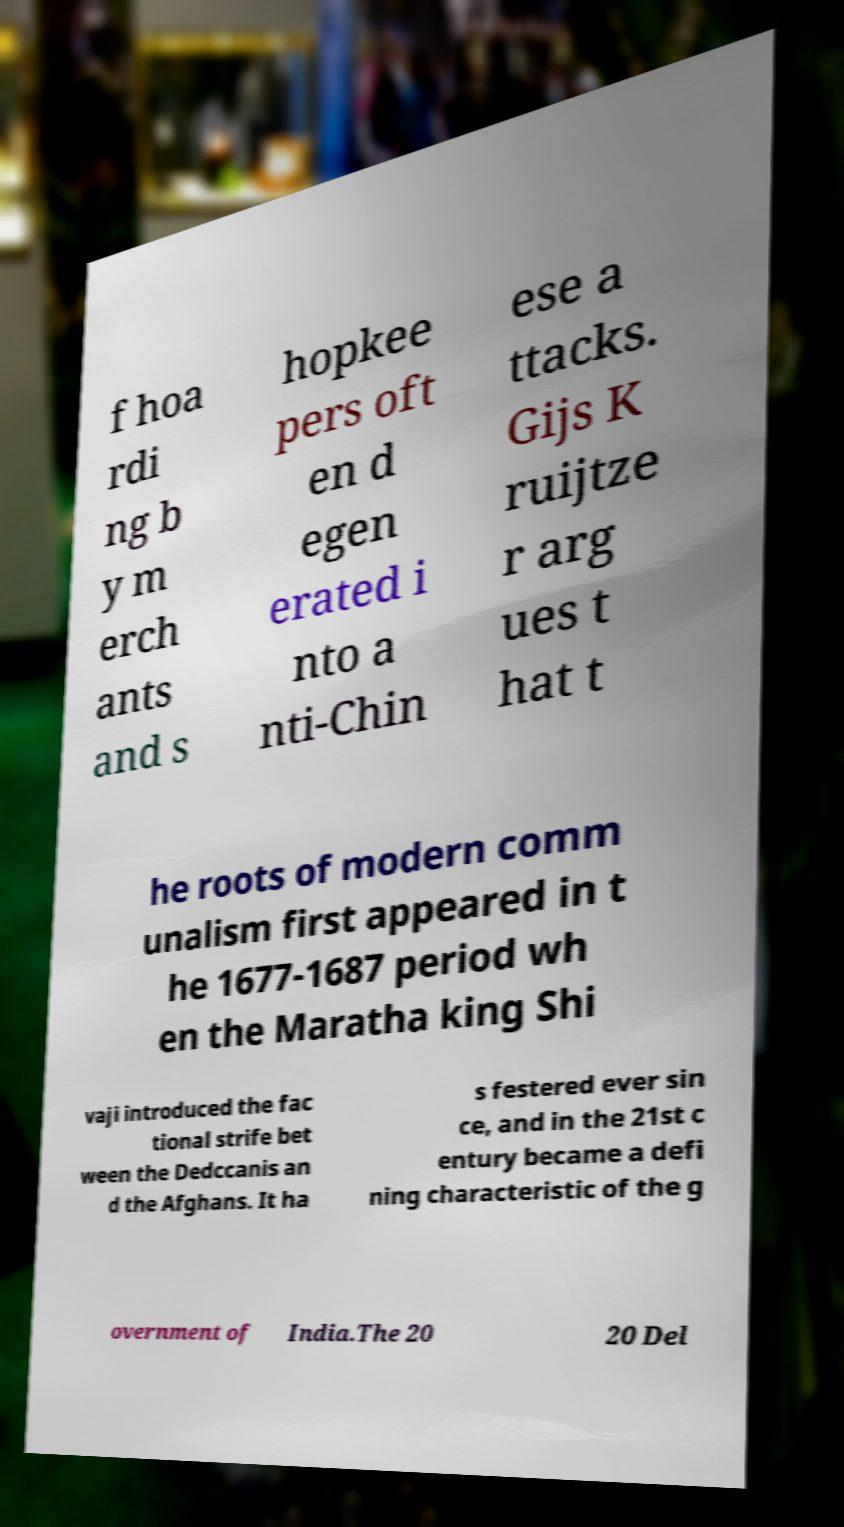For documentation purposes, I need the text within this image transcribed. Could you provide that? f hoa rdi ng b y m erch ants and s hopkee pers oft en d egen erated i nto a nti-Chin ese a ttacks. Gijs K ruijtze r arg ues t hat t he roots of modern comm unalism first appeared in t he 1677-1687 period wh en the Maratha king Shi vaji introduced the fac tional strife bet ween the Dedccanis an d the Afghans. It ha s festered ever sin ce, and in the 21st c entury became a defi ning characteristic of the g overnment of India.The 20 20 Del 